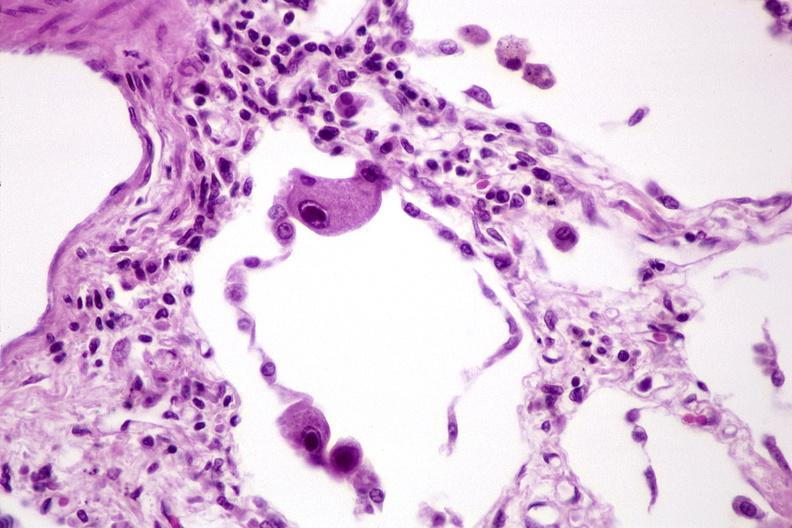what is present?
Answer the question using a single word or phrase. Respiratory 